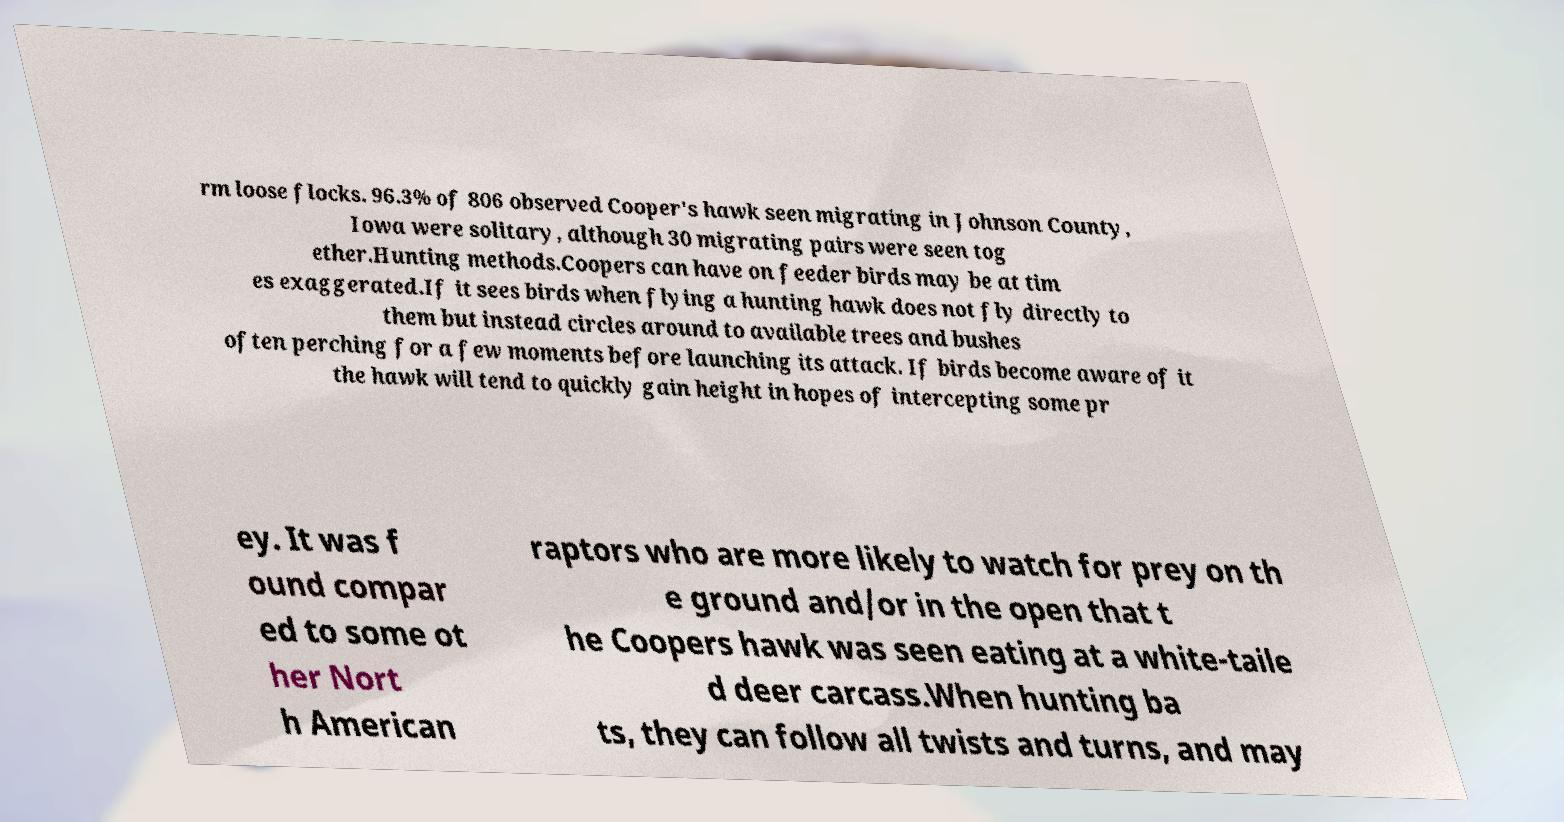Could you extract and type out the text from this image? rm loose flocks. 96.3% of 806 observed Cooper's hawk seen migrating in Johnson County, Iowa were solitary, although 30 migrating pairs were seen tog ether.Hunting methods.Coopers can have on feeder birds may be at tim es exaggerated.If it sees birds when flying a hunting hawk does not fly directly to them but instead circles around to available trees and bushes often perching for a few moments before launching its attack. If birds become aware of it the hawk will tend to quickly gain height in hopes of intercepting some pr ey. It was f ound compar ed to some ot her Nort h American raptors who are more likely to watch for prey on th e ground and/or in the open that t he Coopers hawk was seen eating at a white-taile d deer carcass.When hunting ba ts, they can follow all twists and turns, and may 